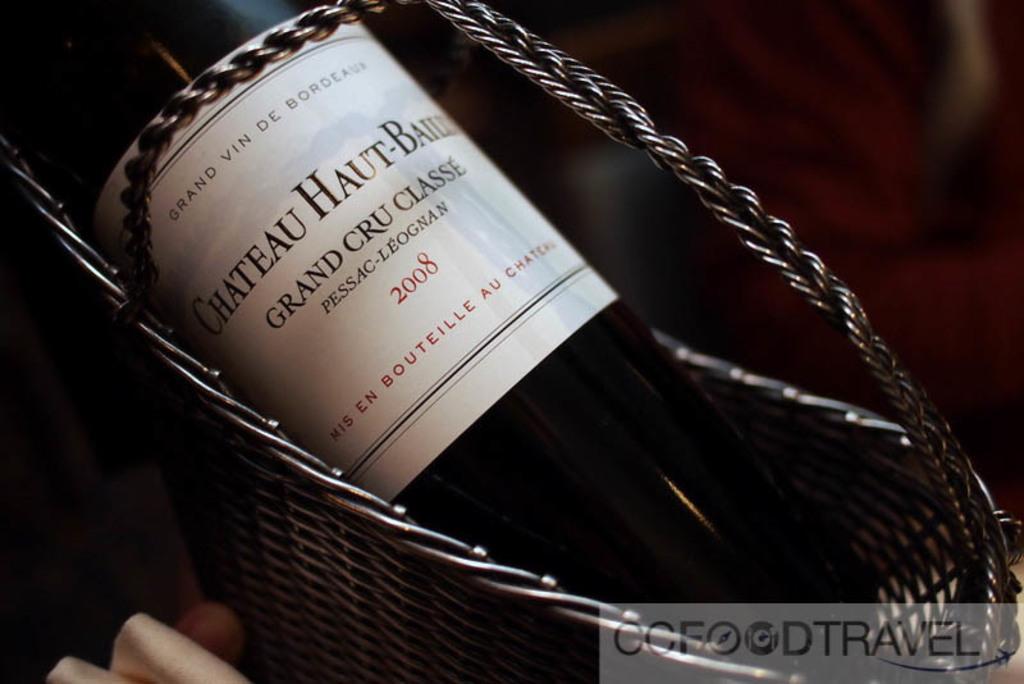What wine is that?
Keep it short and to the point. Grand cru classe . 